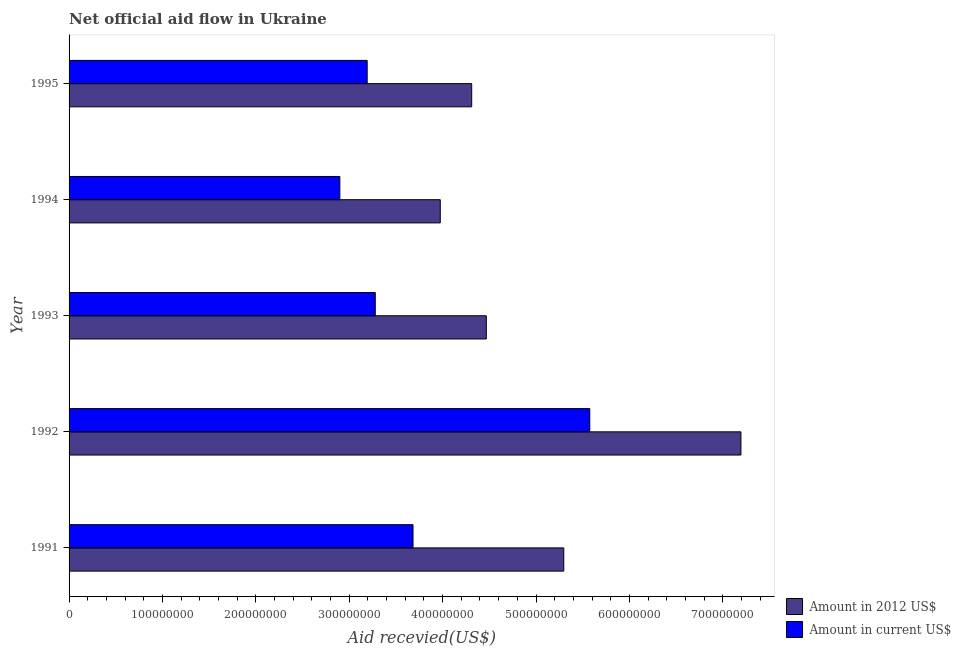How many different coloured bars are there?
Provide a succinct answer. 2. How many groups of bars are there?
Offer a terse response. 5. Are the number of bars on each tick of the Y-axis equal?
Your response must be concise. Yes. How many bars are there on the 4th tick from the bottom?
Your answer should be compact. 2. What is the label of the 5th group of bars from the top?
Offer a terse response. 1991. In how many cases, is the number of bars for a given year not equal to the number of legend labels?
Your answer should be very brief. 0. What is the amount of aid received(expressed in 2012 us$) in 1995?
Ensure brevity in your answer.  4.31e+08. Across all years, what is the maximum amount of aid received(expressed in 2012 us$)?
Your response must be concise. 7.19e+08. Across all years, what is the minimum amount of aid received(expressed in us$)?
Your answer should be compact. 2.90e+08. In which year was the amount of aid received(expressed in us$) maximum?
Offer a very short reply. 1992. What is the total amount of aid received(expressed in 2012 us$) in the graph?
Provide a succinct answer. 2.52e+09. What is the difference between the amount of aid received(expressed in us$) in 1993 and that in 1995?
Offer a very short reply. 8.67e+06. What is the difference between the amount of aid received(expressed in us$) in 1994 and the amount of aid received(expressed in 2012 us$) in 1993?
Your answer should be compact. -1.57e+08. What is the average amount of aid received(expressed in us$) per year?
Give a very brief answer. 3.73e+08. In the year 1995, what is the difference between the amount of aid received(expressed in 2012 us$) and amount of aid received(expressed in us$)?
Your answer should be very brief. 1.12e+08. What is the ratio of the amount of aid received(expressed in us$) in 1991 to that in 1992?
Your answer should be compact. 0.66. What is the difference between the highest and the second highest amount of aid received(expressed in 2012 us$)?
Give a very brief answer. 1.90e+08. What is the difference between the highest and the lowest amount of aid received(expressed in 2012 us$)?
Make the answer very short. 3.22e+08. In how many years, is the amount of aid received(expressed in 2012 us$) greater than the average amount of aid received(expressed in 2012 us$) taken over all years?
Your answer should be compact. 2. Is the sum of the amount of aid received(expressed in 2012 us$) in 1992 and 1993 greater than the maximum amount of aid received(expressed in us$) across all years?
Provide a short and direct response. Yes. What does the 2nd bar from the top in 1994 represents?
Your answer should be compact. Amount in 2012 US$. What does the 1st bar from the bottom in 1992 represents?
Your answer should be very brief. Amount in 2012 US$. Are the values on the major ticks of X-axis written in scientific E-notation?
Make the answer very short. No. Does the graph contain any zero values?
Your answer should be compact. No. Where does the legend appear in the graph?
Make the answer very short. Bottom right. How many legend labels are there?
Make the answer very short. 2. How are the legend labels stacked?
Provide a succinct answer. Vertical. What is the title of the graph?
Give a very brief answer. Net official aid flow in Ukraine. Does "Arms exports" appear as one of the legend labels in the graph?
Offer a terse response. No. What is the label or title of the X-axis?
Give a very brief answer. Aid recevied(US$). What is the Aid recevied(US$) of Amount in 2012 US$ in 1991?
Your answer should be compact. 5.30e+08. What is the Aid recevied(US$) in Amount in current US$ in 1991?
Your response must be concise. 3.68e+08. What is the Aid recevied(US$) of Amount in 2012 US$ in 1992?
Your answer should be compact. 7.19e+08. What is the Aid recevied(US$) of Amount in current US$ in 1992?
Your answer should be compact. 5.58e+08. What is the Aid recevied(US$) in Amount in 2012 US$ in 1993?
Your answer should be very brief. 4.47e+08. What is the Aid recevied(US$) in Amount in current US$ in 1993?
Offer a very short reply. 3.28e+08. What is the Aid recevied(US$) in Amount in 2012 US$ in 1994?
Offer a terse response. 3.97e+08. What is the Aid recevied(US$) in Amount in current US$ in 1994?
Make the answer very short. 2.90e+08. What is the Aid recevied(US$) of Amount in 2012 US$ in 1995?
Your answer should be very brief. 4.31e+08. What is the Aid recevied(US$) of Amount in current US$ in 1995?
Provide a short and direct response. 3.19e+08. Across all years, what is the maximum Aid recevied(US$) of Amount in 2012 US$?
Provide a short and direct response. 7.19e+08. Across all years, what is the maximum Aid recevied(US$) of Amount in current US$?
Ensure brevity in your answer.  5.58e+08. Across all years, what is the minimum Aid recevied(US$) of Amount in 2012 US$?
Make the answer very short. 3.97e+08. Across all years, what is the minimum Aid recevied(US$) in Amount in current US$?
Your response must be concise. 2.90e+08. What is the total Aid recevied(US$) in Amount in 2012 US$ in the graph?
Provide a short and direct response. 2.52e+09. What is the total Aid recevied(US$) of Amount in current US$ in the graph?
Your response must be concise. 1.86e+09. What is the difference between the Aid recevied(US$) of Amount in 2012 US$ in 1991 and that in 1992?
Your answer should be very brief. -1.90e+08. What is the difference between the Aid recevied(US$) of Amount in current US$ in 1991 and that in 1992?
Provide a short and direct response. -1.89e+08. What is the difference between the Aid recevied(US$) in Amount in 2012 US$ in 1991 and that in 1993?
Give a very brief answer. 8.29e+07. What is the difference between the Aid recevied(US$) of Amount in current US$ in 1991 and that in 1993?
Give a very brief answer. 4.04e+07. What is the difference between the Aid recevied(US$) in Amount in 2012 US$ in 1991 and that in 1994?
Your answer should be very brief. 1.32e+08. What is the difference between the Aid recevied(US$) in Amount in current US$ in 1991 and that in 1994?
Your answer should be very brief. 7.84e+07. What is the difference between the Aid recevied(US$) of Amount in 2012 US$ in 1991 and that in 1995?
Offer a terse response. 9.86e+07. What is the difference between the Aid recevied(US$) in Amount in current US$ in 1991 and that in 1995?
Your response must be concise. 4.91e+07. What is the difference between the Aid recevied(US$) of Amount in 2012 US$ in 1992 and that in 1993?
Offer a terse response. 2.73e+08. What is the difference between the Aid recevied(US$) in Amount in current US$ in 1992 and that in 1993?
Offer a terse response. 2.30e+08. What is the difference between the Aid recevied(US$) in Amount in 2012 US$ in 1992 and that in 1994?
Offer a terse response. 3.22e+08. What is the difference between the Aid recevied(US$) in Amount in current US$ in 1992 and that in 1994?
Offer a very short reply. 2.68e+08. What is the difference between the Aid recevied(US$) in Amount in 2012 US$ in 1992 and that in 1995?
Ensure brevity in your answer.  2.88e+08. What is the difference between the Aid recevied(US$) in Amount in current US$ in 1992 and that in 1995?
Provide a short and direct response. 2.38e+08. What is the difference between the Aid recevied(US$) of Amount in 2012 US$ in 1993 and that in 1994?
Give a very brief answer. 4.93e+07. What is the difference between the Aid recevied(US$) of Amount in current US$ in 1993 and that in 1994?
Provide a short and direct response. 3.79e+07. What is the difference between the Aid recevied(US$) of Amount in 2012 US$ in 1993 and that in 1995?
Your answer should be compact. 1.56e+07. What is the difference between the Aid recevied(US$) in Amount in current US$ in 1993 and that in 1995?
Provide a short and direct response. 8.67e+06. What is the difference between the Aid recevied(US$) of Amount in 2012 US$ in 1994 and that in 1995?
Offer a terse response. -3.37e+07. What is the difference between the Aid recevied(US$) in Amount in current US$ in 1994 and that in 1995?
Provide a short and direct response. -2.93e+07. What is the difference between the Aid recevied(US$) of Amount in 2012 US$ in 1991 and the Aid recevied(US$) of Amount in current US$ in 1992?
Your answer should be very brief. -2.79e+07. What is the difference between the Aid recevied(US$) of Amount in 2012 US$ in 1991 and the Aid recevied(US$) of Amount in current US$ in 1993?
Make the answer very short. 2.02e+08. What is the difference between the Aid recevied(US$) of Amount in 2012 US$ in 1991 and the Aid recevied(US$) of Amount in current US$ in 1994?
Keep it short and to the point. 2.40e+08. What is the difference between the Aid recevied(US$) of Amount in 2012 US$ in 1991 and the Aid recevied(US$) of Amount in current US$ in 1995?
Ensure brevity in your answer.  2.11e+08. What is the difference between the Aid recevied(US$) in Amount in 2012 US$ in 1992 and the Aid recevied(US$) in Amount in current US$ in 1993?
Make the answer very short. 3.92e+08. What is the difference between the Aid recevied(US$) in Amount in 2012 US$ in 1992 and the Aid recevied(US$) in Amount in current US$ in 1994?
Provide a succinct answer. 4.30e+08. What is the difference between the Aid recevied(US$) of Amount in 2012 US$ in 1992 and the Aid recevied(US$) of Amount in current US$ in 1995?
Provide a succinct answer. 4.00e+08. What is the difference between the Aid recevied(US$) in Amount in 2012 US$ in 1993 and the Aid recevied(US$) in Amount in current US$ in 1994?
Give a very brief answer. 1.57e+08. What is the difference between the Aid recevied(US$) of Amount in 2012 US$ in 1993 and the Aid recevied(US$) of Amount in current US$ in 1995?
Give a very brief answer. 1.28e+08. What is the difference between the Aid recevied(US$) in Amount in 2012 US$ in 1994 and the Aid recevied(US$) in Amount in current US$ in 1995?
Ensure brevity in your answer.  7.83e+07. What is the average Aid recevied(US$) of Amount in 2012 US$ per year?
Give a very brief answer. 5.05e+08. What is the average Aid recevied(US$) of Amount in current US$ per year?
Offer a terse response. 3.73e+08. In the year 1991, what is the difference between the Aid recevied(US$) in Amount in 2012 US$ and Aid recevied(US$) in Amount in current US$?
Your response must be concise. 1.61e+08. In the year 1992, what is the difference between the Aid recevied(US$) of Amount in 2012 US$ and Aid recevied(US$) of Amount in current US$?
Provide a short and direct response. 1.62e+08. In the year 1993, what is the difference between the Aid recevied(US$) of Amount in 2012 US$ and Aid recevied(US$) of Amount in current US$?
Provide a short and direct response. 1.19e+08. In the year 1994, what is the difference between the Aid recevied(US$) of Amount in 2012 US$ and Aid recevied(US$) of Amount in current US$?
Keep it short and to the point. 1.08e+08. In the year 1995, what is the difference between the Aid recevied(US$) of Amount in 2012 US$ and Aid recevied(US$) of Amount in current US$?
Your answer should be compact. 1.12e+08. What is the ratio of the Aid recevied(US$) of Amount in 2012 US$ in 1991 to that in 1992?
Your answer should be compact. 0.74. What is the ratio of the Aid recevied(US$) in Amount in current US$ in 1991 to that in 1992?
Offer a very short reply. 0.66. What is the ratio of the Aid recevied(US$) of Amount in 2012 US$ in 1991 to that in 1993?
Your answer should be very brief. 1.19. What is the ratio of the Aid recevied(US$) in Amount in current US$ in 1991 to that in 1993?
Offer a very short reply. 1.12. What is the ratio of the Aid recevied(US$) of Amount in 2012 US$ in 1991 to that in 1994?
Offer a very short reply. 1.33. What is the ratio of the Aid recevied(US$) of Amount in current US$ in 1991 to that in 1994?
Your answer should be very brief. 1.27. What is the ratio of the Aid recevied(US$) in Amount in 2012 US$ in 1991 to that in 1995?
Provide a short and direct response. 1.23. What is the ratio of the Aid recevied(US$) in Amount in current US$ in 1991 to that in 1995?
Your answer should be compact. 1.15. What is the ratio of the Aid recevied(US$) in Amount in 2012 US$ in 1992 to that in 1993?
Give a very brief answer. 1.61. What is the ratio of the Aid recevied(US$) of Amount in current US$ in 1992 to that in 1993?
Your answer should be compact. 1.7. What is the ratio of the Aid recevied(US$) of Amount in 2012 US$ in 1992 to that in 1994?
Give a very brief answer. 1.81. What is the ratio of the Aid recevied(US$) in Amount in current US$ in 1992 to that in 1994?
Offer a terse response. 1.92. What is the ratio of the Aid recevied(US$) of Amount in 2012 US$ in 1992 to that in 1995?
Give a very brief answer. 1.67. What is the ratio of the Aid recevied(US$) in Amount in current US$ in 1992 to that in 1995?
Your answer should be very brief. 1.75. What is the ratio of the Aid recevied(US$) of Amount in 2012 US$ in 1993 to that in 1994?
Provide a short and direct response. 1.12. What is the ratio of the Aid recevied(US$) in Amount in current US$ in 1993 to that in 1994?
Give a very brief answer. 1.13. What is the ratio of the Aid recevied(US$) in Amount in 2012 US$ in 1993 to that in 1995?
Ensure brevity in your answer.  1.04. What is the ratio of the Aid recevied(US$) of Amount in current US$ in 1993 to that in 1995?
Ensure brevity in your answer.  1.03. What is the ratio of the Aid recevied(US$) of Amount in 2012 US$ in 1994 to that in 1995?
Your response must be concise. 0.92. What is the ratio of the Aid recevied(US$) in Amount in current US$ in 1994 to that in 1995?
Offer a terse response. 0.91. What is the difference between the highest and the second highest Aid recevied(US$) of Amount in 2012 US$?
Ensure brevity in your answer.  1.90e+08. What is the difference between the highest and the second highest Aid recevied(US$) in Amount in current US$?
Keep it short and to the point. 1.89e+08. What is the difference between the highest and the lowest Aid recevied(US$) in Amount in 2012 US$?
Make the answer very short. 3.22e+08. What is the difference between the highest and the lowest Aid recevied(US$) of Amount in current US$?
Offer a terse response. 2.68e+08. 